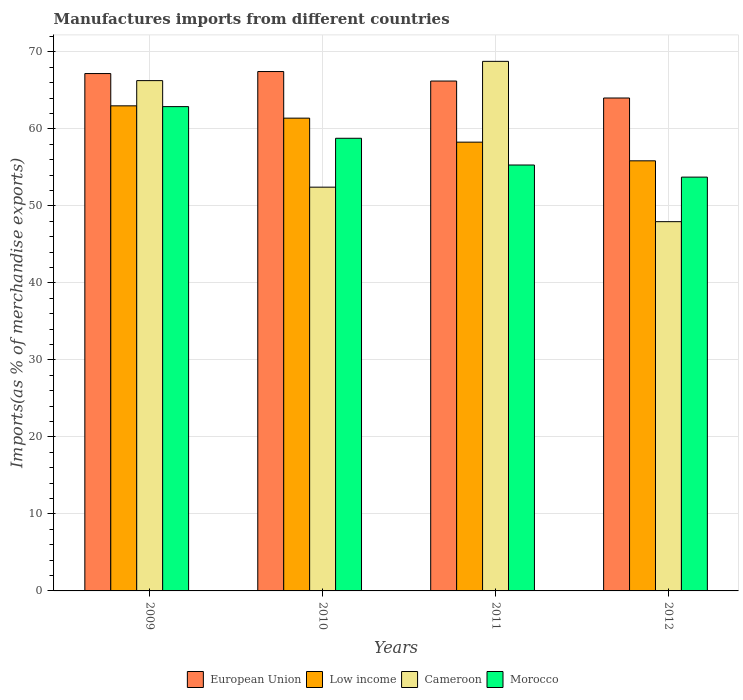How many different coloured bars are there?
Your answer should be compact. 4. Are the number of bars per tick equal to the number of legend labels?
Ensure brevity in your answer.  Yes. How many bars are there on the 1st tick from the right?
Ensure brevity in your answer.  4. What is the percentage of imports to different countries in Cameroon in 2011?
Provide a succinct answer. 68.76. Across all years, what is the maximum percentage of imports to different countries in Morocco?
Offer a very short reply. 62.88. Across all years, what is the minimum percentage of imports to different countries in European Union?
Offer a very short reply. 64. In which year was the percentage of imports to different countries in Cameroon minimum?
Your response must be concise. 2012. What is the total percentage of imports to different countries in Low income in the graph?
Your answer should be very brief. 238.49. What is the difference between the percentage of imports to different countries in European Union in 2009 and that in 2011?
Make the answer very short. 0.97. What is the difference between the percentage of imports to different countries in Morocco in 2009 and the percentage of imports to different countries in Cameroon in 2012?
Ensure brevity in your answer.  14.94. What is the average percentage of imports to different countries in European Union per year?
Provide a short and direct response. 66.21. In the year 2012, what is the difference between the percentage of imports to different countries in Low income and percentage of imports to different countries in European Union?
Keep it short and to the point. -8.16. What is the ratio of the percentage of imports to different countries in Morocco in 2011 to that in 2012?
Your response must be concise. 1.03. Is the percentage of imports to different countries in Cameroon in 2010 less than that in 2012?
Offer a terse response. No. What is the difference between the highest and the second highest percentage of imports to different countries in European Union?
Your answer should be very brief. 0.26. What is the difference between the highest and the lowest percentage of imports to different countries in Cameroon?
Your answer should be very brief. 20.82. Is it the case that in every year, the sum of the percentage of imports to different countries in Low income and percentage of imports to different countries in Morocco is greater than the sum of percentage of imports to different countries in European Union and percentage of imports to different countries in Cameroon?
Your answer should be very brief. No. What does the 3rd bar from the left in 2009 represents?
Offer a terse response. Cameroon. What does the 3rd bar from the right in 2010 represents?
Offer a terse response. Low income. How many bars are there?
Provide a short and direct response. 16. Are the values on the major ticks of Y-axis written in scientific E-notation?
Give a very brief answer. No. Does the graph contain grids?
Provide a succinct answer. Yes. How many legend labels are there?
Your answer should be compact. 4. What is the title of the graph?
Make the answer very short. Manufactures imports from different countries. Does "South Sudan" appear as one of the legend labels in the graph?
Your answer should be very brief. No. What is the label or title of the Y-axis?
Your answer should be compact. Imports(as % of merchandise exports). What is the Imports(as % of merchandise exports) of European Union in 2009?
Provide a succinct answer. 67.18. What is the Imports(as % of merchandise exports) in Low income in 2009?
Keep it short and to the point. 62.99. What is the Imports(as % of merchandise exports) of Cameroon in 2009?
Your answer should be very brief. 66.26. What is the Imports(as % of merchandise exports) of Morocco in 2009?
Offer a terse response. 62.88. What is the Imports(as % of merchandise exports) in European Union in 2010?
Your response must be concise. 67.44. What is the Imports(as % of merchandise exports) in Low income in 2010?
Keep it short and to the point. 61.39. What is the Imports(as % of merchandise exports) of Cameroon in 2010?
Provide a succinct answer. 52.43. What is the Imports(as % of merchandise exports) in Morocco in 2010?
Your answer should be very brief. 58.77. What is the Imports(as % of merchandise exports) in European Union in 2011?
Keep it short and to the point. 66.21. What is the Imports(as % of merchandise exports) in Low income in 2011?
Your answer should be compact. 58.27. What is the Imports(as % of merchandise exports) in Cameroon in 2011?
Ensure brevity in your answer.  68.76. What is the Imports(as % of merchandise exports) in Morocco in 2011?
Keep it short and to the point. 55.3. What is the Imports(as % of merchandise exports) in European Union in 2012?
Provide a short and direct response. 64. What is the Imports(as % of merchandise exports) of Low income in 2012?
Give a very brief answer. 55.85. What is the Imports(as % of merchandise exports) in Cameroon in 2012?
Provide a short and direct response. 47.95. What is the Imports(as % of merchandise exports) in Morocco in 2012?
Provide a short and direct response. 53.73. Across all years, what is the maximum Imports(as % of merchandise exports) in European Union?
Make the answer very short. 67.44. Across all years, what is the maximum Imports(as % of merchandise exports) of Low income?
Provide a succinct answer. 62.99. Across all years, what is the maximum Imports(as % of merchandise exports) of Cameroon?
Make the answer very short. 68.76. Across all years, what is the maximum Imports(as % of merchandise exports) of Morocco?
Provide a succinct answer. 62.88. Across all years, what is the minimum Imports(as % of merchandise exports) in European Union?
Keep it short and to the point. 64. Across all years, what is the minimum Imports(as % of merchandise exports) in Low income?
Ensure brevity in your answer.  55.85. Across all years, what is the minimum Imports(as % of merchandise exports) of Cameroon?
Provide a succinct answer. 47.95. Across all years, what is the minimum Imports(as % of merchandise exports) in Morocco?
Provide a succinct answer. 53.73. What is the total Imports(as % of merchandise exports) of European Union in the graph?
Ensure brevity in your answer.  264.82. What is the total Imports(as % of merchandise exports) of Low income in the graph?
Give a very brief answer. 238.49. What is the total Imports(as % of merchandise exports) in Cameroon in the graph?
Offer a terse response. 235.39. What is the total Imports(as % of merchandise exports) of Morocco in the graph?
Provide a short and direct response. 230.69. What is the difference between the Imports(as % of merchandise exports) of European Union in 2009 and that in 2010?
Keep it short and to the point. -0.26. What is the difference between the Imports(as % of merchandise exports) in Low income in 2009 and that in 2010?
Offer a very short reply. 1.6. What is the difference between the Imports(as % of merchandise exports) in Cameroon in 2009 and that in 2010?
Your answer should be compact. 13.83. What is the difference between the Imports(as % of merchandise exports) of Morocco in 2009 and that in 2010?
Keep it short and to the point. 4.11. What is the difference between the Imports(as % of merchandise exports) in European Union in 2009 and that in 2011?
Offer a terse response. 0.97. What is the difference between the Imports(as % of merchandise exports) in Low income in 2009 and that in 2011?
Provide a short and direct response. 4.72. What is the difference between the Imports(as % of merchandise exports) in Cameroon in 2009 and that in 2011?
Keep it short and to the point. -2.5. What is the difference between the Imports(as % of merchandise exports) of Morocco in 2009 and that in 2011?
Provide a short and direct response. 7.58. What is the difference between the Imports(as % of merchandise exports) of European Union in 2009 and that in 2012?
Give a very brief answer. 3.18. What is the difference between the Imports(as % of merchandise exports) of Low income in 2009 and that in 2012?
Provide a succinct answer. 7.14. What is the difference between the Imports(as % of merchandise exports) in Cameroon in 2009 and that in 2012?
Provide a short and direct response. 18.31. What is the difference between the Imports(as % of merchandise exports) in Morocco in 2009 and that in 2012?
Ensure brevity in your answer.  9.15. What is the difference between the Imports(as % of merchandise exports) of European Union in 2010 and that in 2011?
Provide a succinct answer. 1.23. What is the difference between the Imports(as % of merchandise exports) of Low income in 2010 and that in 2011?
Provide a succinct answer. 3.12. What is the difference between the Imports(as % of merchandise exports) in Cameroon in 2010 and that in 2011?
Your answer should be compact. -16.34. What is the difference between the Imports(as % of merchandise exports) in Morocco in 2010 and that in 2011?
Your answer should be compact. 3.47. What is the difference between the Imports(as % of merchandise exports) in European Union in 2010 and that in 2012?
Make the answer very short. 3.44. What is the difference between the Imports(as % of merchandise exports) of Low income in 2010 and that in 2012?
Provide a short and direct response. 5.54. What is the difference between the Imports(as % of merchandise exports) in Cameroon in 2010 and that in 2012?
Keep it short and to the point. 4.48. What is the difference between the Imports(as % of merchandise exports) in Morocco in 2010 and that in 2012?
Make the answer very short. 5.04. What is the difference between the Imports(as % of merchandise exports) of European Union in 2011 and that in 2012?
Provide a short and direct response. 2.2. What is the difference between the Imports(as % of merchandise exports) in Low income in 2011 and that in 2012?
Offer a terse response. 2.42. What is the difference between the Imports(as % of merchandise exports) of Cameroon in 2011 and that in 2012?
Offer a very short reply. 20.82. What is the difference between the Imports(as % of merchandise exports) of Morocco in 2011 and that in 2012?
Offer a very short reply. 1.57. What is the difference between the Imports(as % of merchandise exports) of European Union in 2009 and the Imports(as % of merchandise exports) of Low income in 2010?
Offer a terse response. 5.79. What is the difference between the Imports(as % of merchandise exports) of European Union in 2009 and the Imports(as % of merchandise exports) of Cameroon in 2010?
Give a very brief answer. 14.75. What is the difference between the Imports(as % of merchandise exports) of European Union in 2009 and the Imports(as % of merchandise exports) of Morocco in 2010?
Your answer should be very brief. 8.4. What is the difference between the Imports(as % of merchandise exports) of Low income in 2009 and the Imports(as % of merchandise exports) of Cameroon in 2010?
Ensure brevity in your answer.  10.56. What is the difference between the Imports(as % of merchandise exports) in Low income in 2009 and the Imports(as % of merchandise exports) in Morocco in 2010?
Keep it short and to the point. 4.21. What is the difference between the Imports(as % of merchandise exports) of Cameroon in 2009 and the Imports(as % of merchandise exports) of Morocco in 2010?
Offer a very short reply. 7.49. What is the difference between the Imports(as % of merchandise exports) of European Union in 2009 and the Imports(as % of merchandise exports) of Low income in 2011?
Your response must be concise. 8.91. What is the difference between the Imports(as % of merchandise exports) of European Union in 2009 and the Imports(as % of merchandise exports) of Cameroon in 2011?
Ensure brevity in your answer.  -1.58. What is the difference between the Imports(as % of merchandise exports) in European Union in 2009 and the Imports(as % of merchandise exports) in Morocco in 2011?
Give a very brief answer. 11.88. What is the difference between the Imports(as % of merchandise exports) in Low income in 2009 and the Imports(as % of merchandise exports) in Cameroon in 2011?
Keep it short and to the point. -5.78. What is the difference between the Imports(as % of merchandise exports) in Low income in 2009 and the Imports(as % of merchandise exports) in Morocco in 2011?
Offer a terse response. 7.68. What is the difference between the Imports(as % of merchandise exports) of Cameroon in 2009 and the Imports(as % of merchandise exports) of Morocco in 2011?
Your response must be concise. 10.96. What is the difference between the Imports(as % of merchandise exports) of European Union in 2009 and the Imports(as % of merchandise exports) of Low income in 2012?
Ensure brevity in your answer.  11.33. What is the difference between the Imports(as % of merchandise exports) in European Union in 2009 and the Imports(as % of merchandise exports) in Cameroon in 2012?
Your response must be concise. 19.23. What is the difference between the Imports(as % of merchandise exports) in European Union in 2009 and the Imports(as % of merchandise exports) in Morocco in 2012?
Your answer should be very brief. 13.45. What is the difference between the Imports(as % of merchandise exports) of Low income in 2009 and the Imports(as % of merchandise exports) of Cameroon in 2012?
Make the answer very short. 15.04. What is the difference between the Imports(as % of merchandise exports) in Low income in 2009 and the Imports(as % of merchandise exports) in Morocco in 2012?
Provide a short and direct response. 9.26. What is the difference between the Imports(as % of merchandise exports) in Cameroon in 2009 and the Imports(as % of merchandise exports) in Morocco in 2012?
Provide a succinct answer. 12.53. What is the difference between the Imports(as % of merchandise exports) in European Union in 2010 and the Imports(as % of merchandise exports) in Low income in 2011?
Offer a terse response. 9.17. What is the difference between the Imports(as % of merchandise exports) of European Union in 2010 and the Imports(as % of merchandise exports) of Cameroon in 2011?
Keep it short and to the point. -1.32. What is the difference between the Imports(as % of merchandise exports) in European Union in 2010 and the Imports(as % of merchandise exports) in Morocco in 2011?
Offer a very short reply. 12.14. What is the difference between the Imports(as % of merchandise exports) in Low income in 2010 and the Imports(as % of merchandise exports) in Cameroon in 2011?
Your answer should be compact. -7.37. What is the difference between the Imports(as % of merchandise exports) in Low income in 2010 and the Imports(as % of merchandise exports) in Morocco in 2011?
Your response must be concise. 6.08. What is the difference between the Imports(as % of merchandise exports) of Cameroon in 2010 and the Imports(as % of merchandise exports) of Morocco in 2011?
Keep it short and to the point. -2.88. What is the difference between the Imports(as % of merchandise exports) of European Union in 2010 and the Imports(as % of merchandise exports) of Low income in 2012?
Provide a short and direct response. 11.59. What is the difference between the Imports(as % of merchandise exports) in European Union in 2010 and the Imports(as % of merchandise exports) in Cameroon in 2012?
Offer a terse response. 19.49. What is the difference between the Imports(as % of merchandise exports) in European Union in 2010 and the Imports(as % of merchandise exports) in Morocco in 2012?
Make the answer very short. 13.71. What is the difference between the Imports(as % of merchandise exports) in Low income in 2010 and the Imports(as % of merchandise exports) in Cameroon in 2012?
Provide a short and direct response. 13.44. What is the difference between the Imports(as % of merchandise exports) in Low income in 2010 and the Imports(as % of merchandise exports) in Morocco in 2012?
Give a very brief answer. 7.66. What is the difference between the Imports(as % of merchandise exports) of Cameroon in 2010 and the Imports(as % of merchandise exports) of Morocco in 2012?
Your answer should be very brief. -1.3. What is the difference between the Imports(as % of merchandise exports) in European Union in 2011 and the Imports(as % of merchandise exports) in Low income in 2012?
Your answer should be compact. 10.36. What is the difference between the Imports(as % of merchandise exports) of European Union in 2011 and the Imports(as % of merchandise exports) of Cameroon in 2012?
Offer a very short reply. 18.26. What is the difference between the Imports(as % of merchandise exports) in European Union in 2011 and the Imports(as % of merchandise exports) in Morocco in 2012?
Provide a succinct answer. 12.48. What is the difference between the Imports(as % of merchandise exports) in Low income in 2011 and the Imports(as % of merchandise exports) in Cameroon in 2012?
Offer a very short reply. 10.32. What is the difference between the Imports(as % of merchandise exports) of Low income in 2011 and the Imports(as % of merchandise exports) of Morocco in 2012?
Your response must be concise. 4.54. What is the difference between the Imports(as % of merchandise exports) in Cameroon in 2011 and the Imports(as % of merchandise exports) in Morocco in 2012?
Keep it short and to the point. 15.03. What is the average Imports(as % of merchandise exports) in European Union per year?
Your response must be concise. 66.21. What is the average Imports(as % of merchandise exports) of Low income per year?
Offer a very short reply. 59.62. What is the average Imports(as % of merchandise exports) in Cameroon per year?
Make the answer very short. 58.85. What is the average Imports(as % of merchandise exports) of Morocco per year?
Your answer should be compact. 57.67. In the year 2009, what is the difference between the Imports(as % of merchandise exports) in European Union and Imports(as % of merchandise exports) in Low income?
Keep it short and to the point. 4.19. In the year 2009, what is the difference between the Imports(as % of merchandise exports) of European Union and Imports(as % of merchandise exports) of Cameroon?
Offer a terse response. 0.92. In the year 2009, what is the difference between the Imports(as % of merchandise exports) of European Union and Imports(as % of merchandise exports) of Morocco?
Keep it short and to the point. 4.29. In the year 2009, what is the difference between the Imports(as % of merchandise exports) of Low income and Imports(as % of merchandise exports) of Cameroon?
Your answer should be very brief. -3.27. In the year 2009, what is the difference between the Imports(as % of merchandise exports) in Low income and Imports(as % of merchandise exports) in Morocco?
Ensure brevity in your answer.  0.1. In the year 2009, what is the difference between the Imports(as % of merchandise exports) of Cameroon and Imports(as % of merchandise exports) of Morocco?
Offer a very short reply. 3.38. In the year 2010, what is the difference between the Imports(as % of merchandise exports) of European Union and Imports(as % of merchandise exports) of Low income?
Provide a succinct answer. 6.05. In the year 2010, what is the difference between the Imports(as % of merchandise exports) of European Union and Imports(as % of merchandise exports) of Cameroon?
Your response must be concise. 15.01. In the year 2010, what is the difference between the Imports(as % of merchandise exports) in European Union and Imports(as % of merchandise exports) in Morocco?
Your response must be concise. 8.66. In the year 2010, what is the difference between the Imports(as % of merchandise exports) of Low income and Imports(as % of merchandise exports) of Cameroon?
Your response must be concise. 8.96. In the year 2010, what is the difference between the Imports(as % of merchandise exports) in Low income and Imports(as % of merchandise exports) in Morocco?
Make the answer very short. 2.61. In the year 2010, what is the difference between the Imports(as % of merchandise exports) in Cameroon and Imports(as % of merchandise exports) in Morocco?
Your answer should be compact. -6.35. In the year 2011, what is the difference between the Imports(as % of merchandise exports) of European Union and Imports(as % of merchandise exports) of Low income?
Your answer should be compact. 7.94. In the year 2011, what is the difference between the Imports(as % of merchandise exports) of European Union and Imports(as % of merchandise exports) of Cameroon?
Your answer should be very brief. -2.56. In the year 2011, what is the difference between the Imports(as % of merchandise exports) of European Union and Imports(as % of merchandise exports) of Morocco?
Ensure brevity in your answer.  10.9. In the year 2011, what is the difference between the Imports(as % of merchandise exports) in Low income and Imports(as % of merchandise exports) in Cameroon?
Your answer should be very brief. -10.49. In the year 2011, what is the difference between the Imports(as % of merchandise exports) in Low income and Imports(as % of merchandise exports) in Morocco?
Make the answer very short. 2.97. In the year 2011, what is the difference between the Imports(as % of merchandise exports) in Cameroon and Imports(as % of merchandise exports) in Morocco?
Ensure brevity in your answer.  13.46. In the year 2012, what is the difference between the Imports(as % of merchandise exports) in European Union and Imports(as % of merchandise exports) in Low income?
Keep it short and to the point. 8.16. In the year 2012, what is the difference between the Imports(as % of merchandise exports) in European Union and Imports(as % of merchandise exports) in Cameroon?
Give a very brief answer. 16.06. In the year 2012, what is the difference between the Imports(as % of merchandise exports) in European Union and Imports(as % of merchandise exports) in Morocco?
Ensure brevity in your answer.  10.27. In the year 2012, what is the difference between the Imports(as % of merchandise exports) of Low income and Imports(as % of merchandise exports) of Cameroon?
Make the answer very short. 7.9. In the year 2012, what is the difference between the Imports(as % of merchandise exports) of Low income and Imports(as % of merchandise exports) of Morocco?
Your response must be concise. 2.12. In the year 2012, what is the difference between the Imports(as % of merchandise exports) in Cameroon and Imports(as % of merchandise exports) in Morocco?
Your response must be concise. -5.78. What is the ratio of the Imports(as % of merchandise exports) in European Union in 2009 to that in 2010?
Ensure brevity in your answer.  1. What is the ratio of the Imports(as % of merchandise exports) in Cameroon in 2009 to that in 2010?
Give a very brief answer. 1.26. What is the ratio of the Imports(as % of merchandise exports) of Morocco in 2009 to that in 2010?
Your answer should be compact. 1.07. What is the ratio of the Imports(as % of merchandise exports) in European Union in 2009 to that in 2011?
Give a very brief answer. 1.01. What is the ratio of the Imports(as % of merchandise exports) in Low income in 2009 to that in 2011?
Offer a very short reply. 1.08. What is the ratio of the Imports(as % of merchandise exports) of Cameroon in 2009 to that in 2011?
Your answer should be compact. 0.96. What is the ratio of the Imports(as % of merchandise exports) in Morocco in 2009 to that in 2011?
Provide a succinct answer. 1.14. What is the ratio of the Imports(as % of merchandise exports) of European Union in 2009 to that in 2012?
Give a very brief answer. 1.05. What is the ratio of the Imports(as % of merchandise exports) in Low income in 2009 to that in 2012?
Your response must be concise. 1.13. What is the ratio of the Imports(as % of merchandise exports) of Cameroon in 2009 to that in 2012?
Make the answer very short. 1.38. What is the ratio of the Imports(as % of merchandise exports) in Morocco in 2009 to that in 2012?
Offer a very short reply. 1.17. What is the ratio of the Imports(as % of merchandise exports) of European Union in 2010 to that in 2011?
Make the answer very short. 1.02. What is the ratio of the Imports(as % of merchandise exports) in Low income in 2010 to that in 2011?
Your answer should be very brief. 1.05. What is the ratio of the Imports(as % of merchandise exports) of Cameroon in 2010 to that in 2011?
Make the answer very short. 0.76. What is the ratio of the Imports(as % of merchandise exports) of Morocco in 2010 to that in 2011?
Your response must be concise. 1.06. What is the ratio of the Imports(as % of merchandise exports) of European Union in 2010 to that in 2012?
Provide a succinct answer. 1.05. What is the ratio of the Imports(as % of merchandise exports) of Low income in 2010 to that in 2012?
Give a very brief answer. 1.1. What is the ratio of the Imports(as % of merchandise exports) in Cameroon in 2010 to that in 2012?
Your response must be concise. 1.09. What is the ratio of the Imports(as % of merchandise exports) of Morocco in 2010 to that in 2012?
Your answer should be compact. 1.09. What is the ratio of the Imports(as % of merchandise exports) of European Union in 2011 to that in 2012?
Provide a short and direct response. 1.03. What is the ratio of the Imports(as % of merchandise exports) of Low income in 2011 to that in 2012?
Give a very brief answer. 1.04. What is the ratio of the Imports(as % of merchandise exports) in Cameroon in 2011 to that in 2012?
Your answer should be very brief. 1.43. What is the ratio of the Imports(as % of merchandise exports) of Morocco in 2011 to that in 2012?
Keep it short and to the point. 1.03. What is the difference between the highest and the second highest Imports(as % of merchandise exports) of European Union?
Your answer should be very brief. 0.26. What is the difference between the highest and the second highest Imports(as % of merchandise exports) in Low income?
Make the answer very short. 1.6. What is the difference between the highest and the second highest Imports(as % of merchandise exports) of Cameroon?
Keep it short and to the point. 2.5. What is the difference between the highest and the second highest Imports(as % of merchandise exports) of Morocco?
Keep it short and to the point. 4.11. What is the difference between the highest and the lowest Imports(as % of merchandise exports) in European Union?
Make the answer very short. 3.44. What is the difference between the highest and the lowest Imports(as % of merchandise exports) in Low income?
Your response must be concise. 7.14. What is the difference between the highest and the lowest Imports(as % of merchandise exports) in Cameroon?
Make the answer very short. 20.82. What is the difference between the highest and the lowest Imports(as % of merchandise exports) of Morocco?
Make the answer very short. 9.15. 